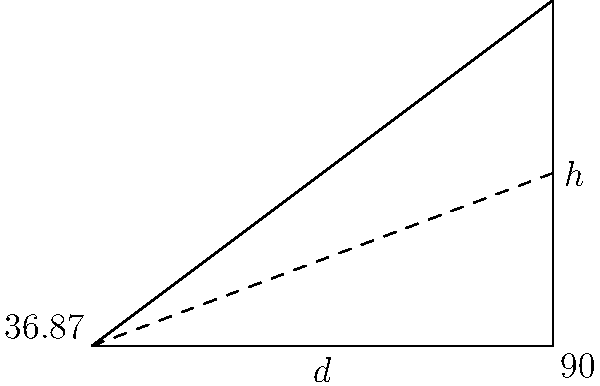For a video mapping show, you need to calculate the field of view (FOV) for a projector with a specific lens. Given a projection distance (d) of 4 meters and a projection height (h) of 3 meters, what is the vertical FOV of the projector lens? To calculate the vertical field of view (FOV) for the projector lens, we can use basic trigonometry. Here's a step-by-step approach:

1. Identify the right triangle formed by the projector, the bottom edge of the projection, and the top edge of the projection.

2. The projection distance (d) forms the base of the triangle, and the projection height (h) forms the opposite side.

3. We need to find the angle at the projector, which is half of the vertical FOV.

4. Use the arctangent function to calculate this angle:
   $\theta = \arctan(\frac{h}{2d})$

5. Substitute the given values:
   $\theta = \arctan(\frac{3}{2 \cdot 4})$
   $\theta = \arctan(0.375)$
   $\theta \approx 20.556°$

6. This angle represents half of the vertical FOV. To get the full vertical FOV, multiply by 2:
   $\text{Vertical FOV} = 2 \theta \approx 2 \cdot 20.556° = 41.112°$

7. Round to two decimal places for the final answer.
Answer: 41.11° 